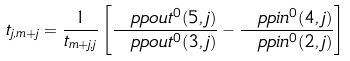<formula> <loc_0><loc_0><loc_500><loc_500>t _ { j , m + j } = \frac { 1 } { t _ { m + j , j } } \left [ \frac { \ p p o u t ^ { 0 } ( 5 , j ) } { \ p p o u t ^ { 0 } ( 3 , j ) } - \frac { \ p p i n ^ { 0 } ( 4 , j ) } { \ p p i n ^ { 0 } ( 2 , j ) } \right ]</formula> 